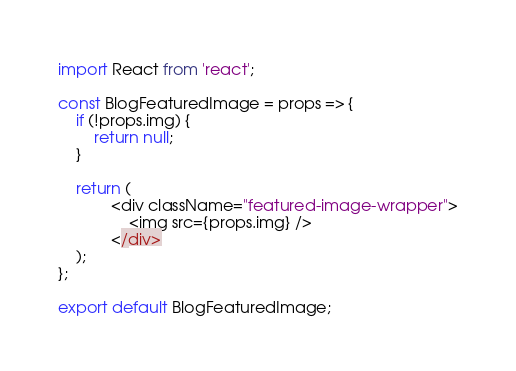Convert code to text. <code><loc_0><loc_0><loc_500><loc_500><_JavaScript_>import React from 'react';

const BlogFeaturedImage = props => {
    if (!props.img) {
        return null;
    }

    return (
            <div className="featured-image-wrapper">
                <img src={props.img} />
            </div>
    );
};

export default BlogFeaturedImage;</code> 